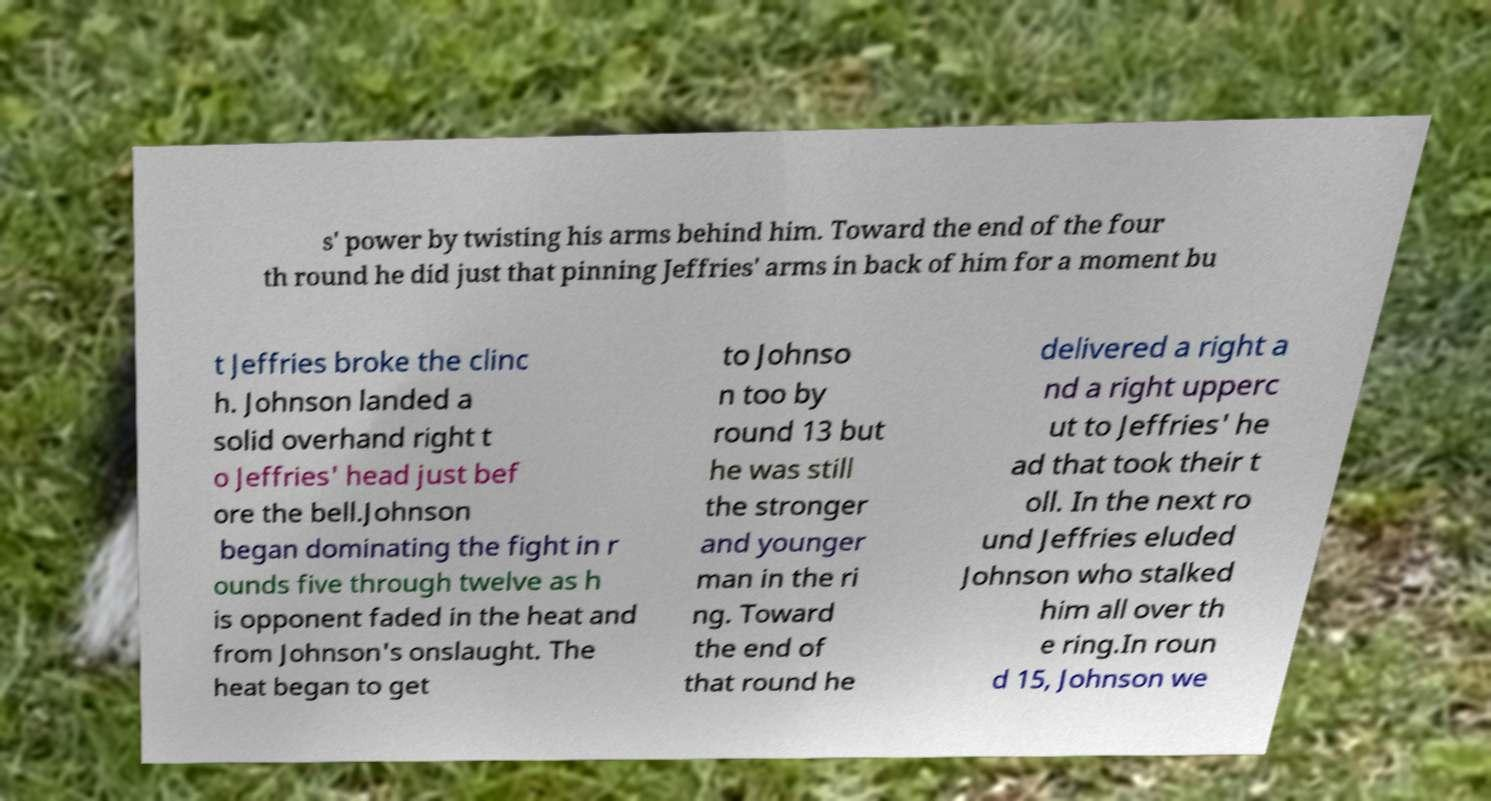Can you accurately transcribe the text from the provided image for me? s' power by twisting his arms behind him. Toward the end of the four th round he did just that pinning Jeffries' arms in back of him for a moment bu t Jeffries broke the clinc h. Johnson landed a solid overhand right t o Jeffries' head just bef ore the bell.Johnson began dominating the fight in r ounds five through twelve as h is opponent faded in the heat and from Johnson's onslaught. The heat began to get to Johnso n too by round 13 but he was still the stronger and younger man in the ri ng. Toward the end of that round he delivered a right a nd a right upperc ut to Jeffries' he ad that took their t oll. In the next ro und Jeffries eluded Johnson who stalked him all over th e ring.In roun d 15, Johnson we 